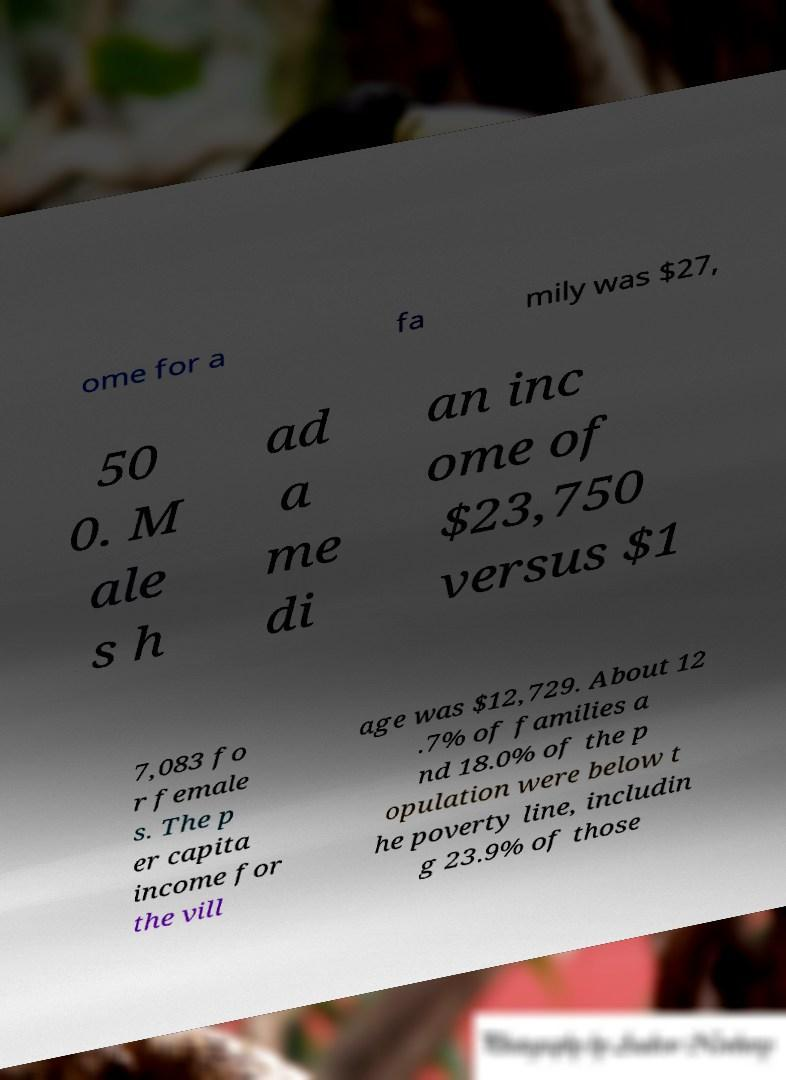Please identify and transcribe the text found in this image. ome for a fa mily was $27, 50 0. M ale s h ad a me di an inc ome of $23,750 versus $1 7,083 fo r female s. The p er capita income for the vill age was $12,729. About 12 .7% of families a nd 18.0% of the p opulation were below t he poverty line, includin g 23.9% of those 